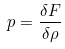Convert formula to latex. <formula><loc_0><loc_0><loc_500><loc_500>p = \frac { \delta F } { \delta \rho }</formula> 